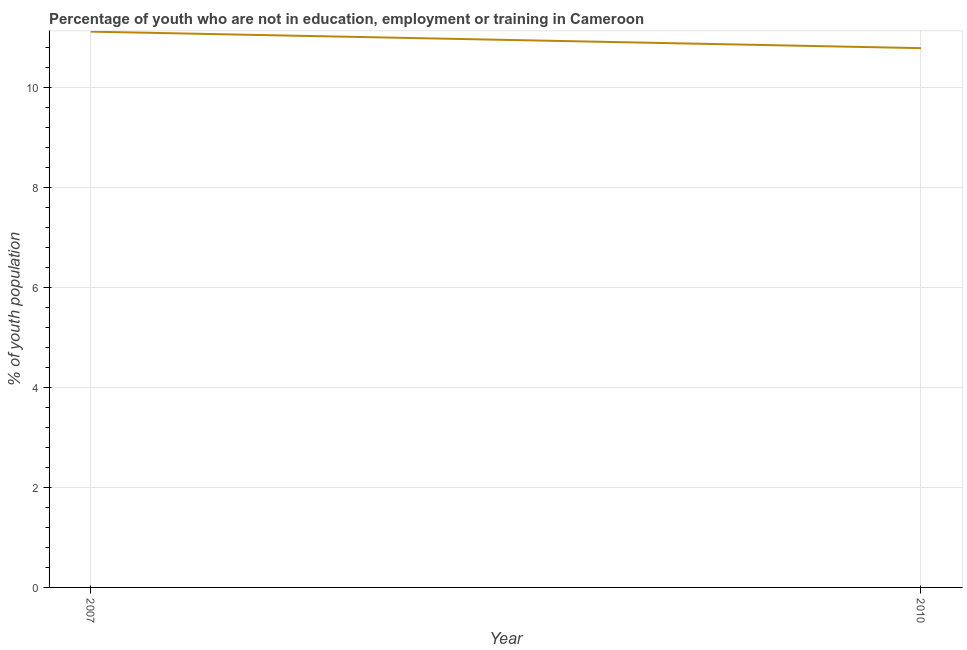What is the unemployed youth population in 2010?
Keep it short and to the point. 10.79. Across all years, what is the maximum unemployed youth population?
Your answer should be very brief. 11.12. Across all years, what is the minimum unemployed youth population?
Ensure brevity in your answer.  10.79. In which year was the unemployed youth population maximum?
Offer a very short reply. 2007. In which year was the unemployed youth population minimum?
Offer a very short reply. 2010. What is the sum of the unemployed youth population?
Provide a succinct answer. 21.91. What is the difference between the unemployed youth population in 2007 and 2010?
Ensure brevity in your answer.  0.33. What is the average unemployed youth population per year?
Offer a terse response. 10.95. What is the median unemployed youth population?
Your answer should be compact. 10.95. In how many years, is the unemployed youth population greater than 10 %?
Your answer should be compact. 2. What is the ratio of the unemployed youth population in 2007 to that in 2010?
Offer a terse response. 1.03. Is the unemployed youth population in 2007 less than that in 2010?
Ensure brevity in your answer.  No. Does the unemployed youth population monotonically increase over the years?
Your answer should be very brief. No. How many years are there in the graph?
Provide a short and direct response. 2. What is the difference between two consecutive major ticks on the Y-axis?
Give a very brief answer. 2. Are the values on the major ticks of Y-axis written in scientific E-notation?
Your answer should be very brief. No. Does the graph contain grids?
Your answer should be very brief. Yes. What is the title of the graph?
Ensure brevity in your answer.  Percentage of youth who are not in education, employment or training in Cameroon. What is the label or title of the Y-axis?
Provide a short and direct response. % of youth population. What is the % of youth population in 2007?
Provide a succinct answer. 11.12. What is the % of youth population of 2010?
Your answer should be compact. 10.79. What is the difference between the % of youth population in 2007 and 2010?
Offer a terse response. 0.33. What is the ratio of the % of youth population in 2007 to that in 2010?
Ensure brevity in your answer.  1.03. 